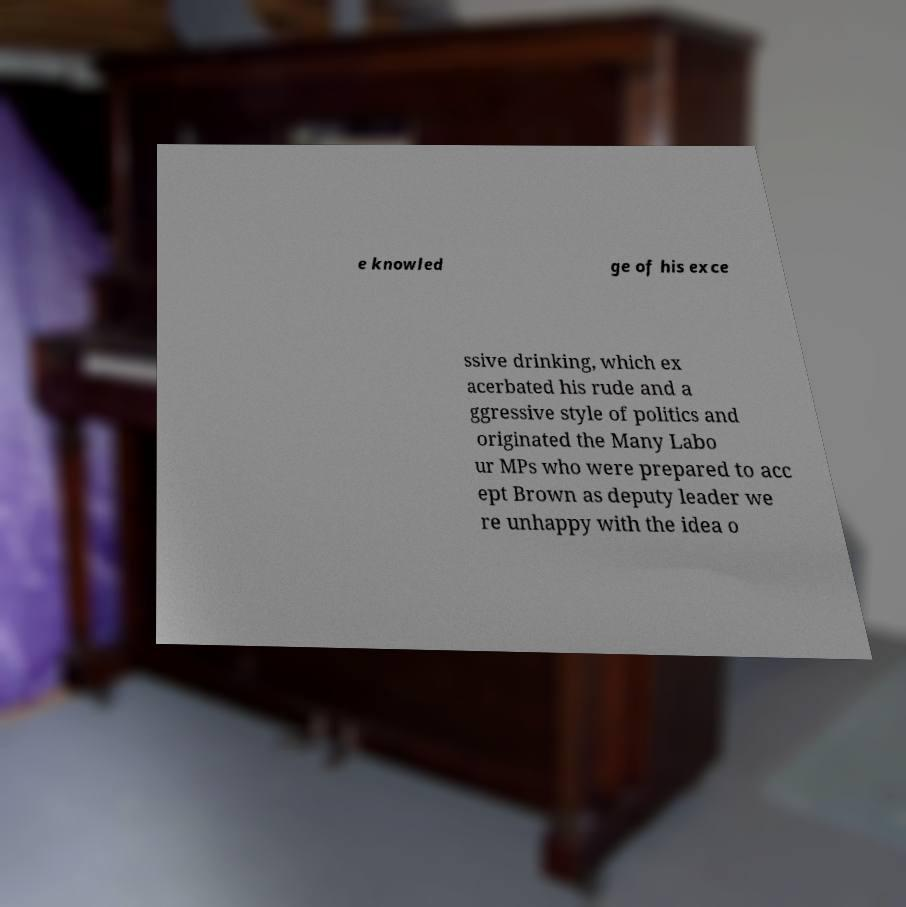Please identify and transcribe the text found in this image. e knowled ge of his exce ssive drinking, which ex acerbated his rude and a ggressive style of politics and originated the Many Labo ur MPs who were prepared to acc ept Brown as deputy leader we re unhappy with the idea o 